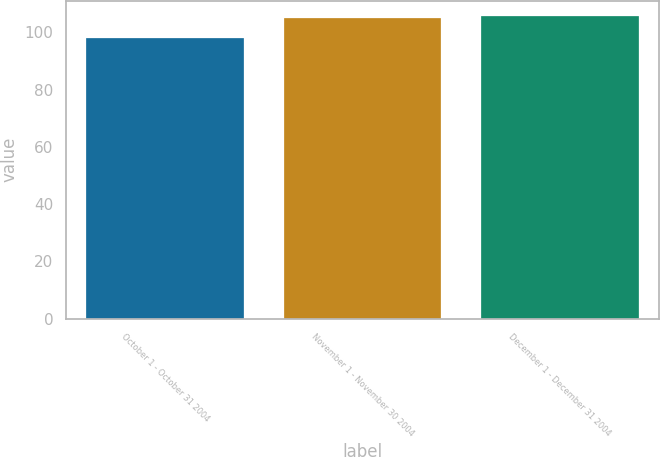Convert chart to OTSL. <chart><loc_0><loc_0><loc_500><loc_500><bar_chart><fcel>October 1 - October 31 2004<fcel>November 1 - November 30 2004<fcel>December 1 - December 31 2004<nl><fcel>98.05<fcel>104.95<fcel>105.72<nl></chart> 